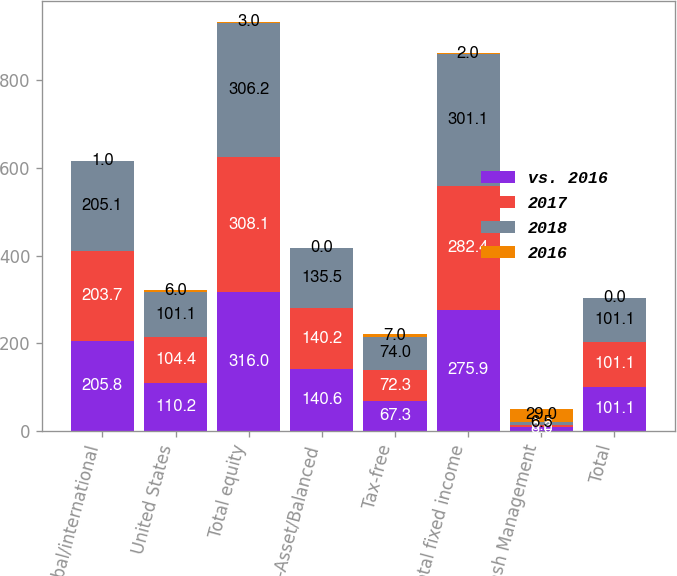Convert chart to OTSL. <chart><loc_0><loc_0><loc_500><loc_500><stacked_bar_chart><ecel><fcel>Global/international<fcel>United States<fcel>Total equity<fcel>Multi-Asset/Balanced<fcel>Tax-free<fcel>Total fixed income<fcel>Cash Management<fcel>Total<nl><fcel>vs. 2016<fcel>205.8<fcel>110.2<fcel>316<fcel>140.6<fcel>67.3<fcel>275.9<fcel>8<fcel>101.1<nl><fcel>2017<fcel>203.7<fcel>104.4<fcel>308.1<fcel>140.2<fcel>72.3<fcel>282.4<fcel>6.2<fcel>101.1<nl><fcel>2018<fcel>205.1<fcel>101.1<fcel>306.2<fcel>135.5<fcel>74<fcel>301.1<fcel>6.5<fcel>101.1<nl><fcel>2016<fcel>1<fcel>6<fcel>3<fcel>0<fcel>7<fcel>2<fcel>29<fcel>0<nl></chart> 